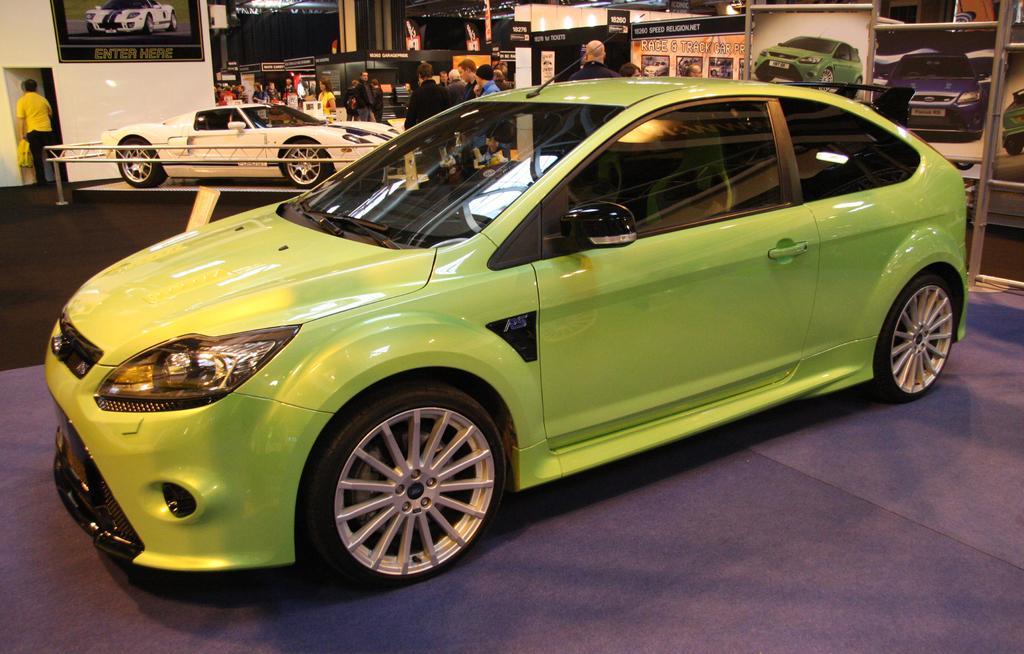How would you summarize this image in a sentence or two? As we can see in the image there are different colors of cars, banners, few people here and there and wall. 